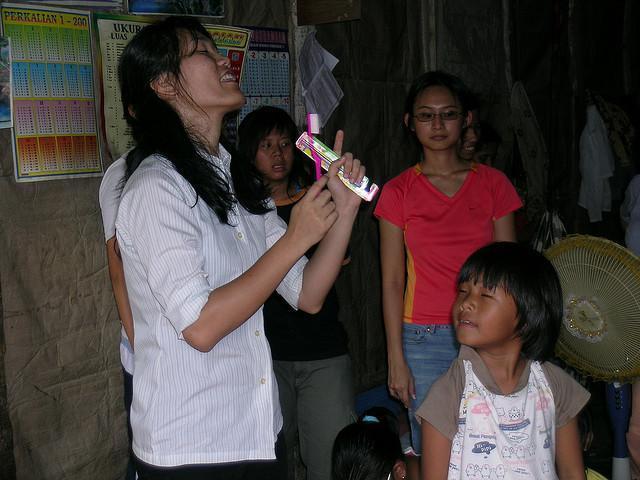How many people in this scene are wearing glasses?
Give a very brief answer. 1. How many kids have hats?
Give a very brief answer. 0. How many people are in the photo?
Give a very brief answer. 6. 